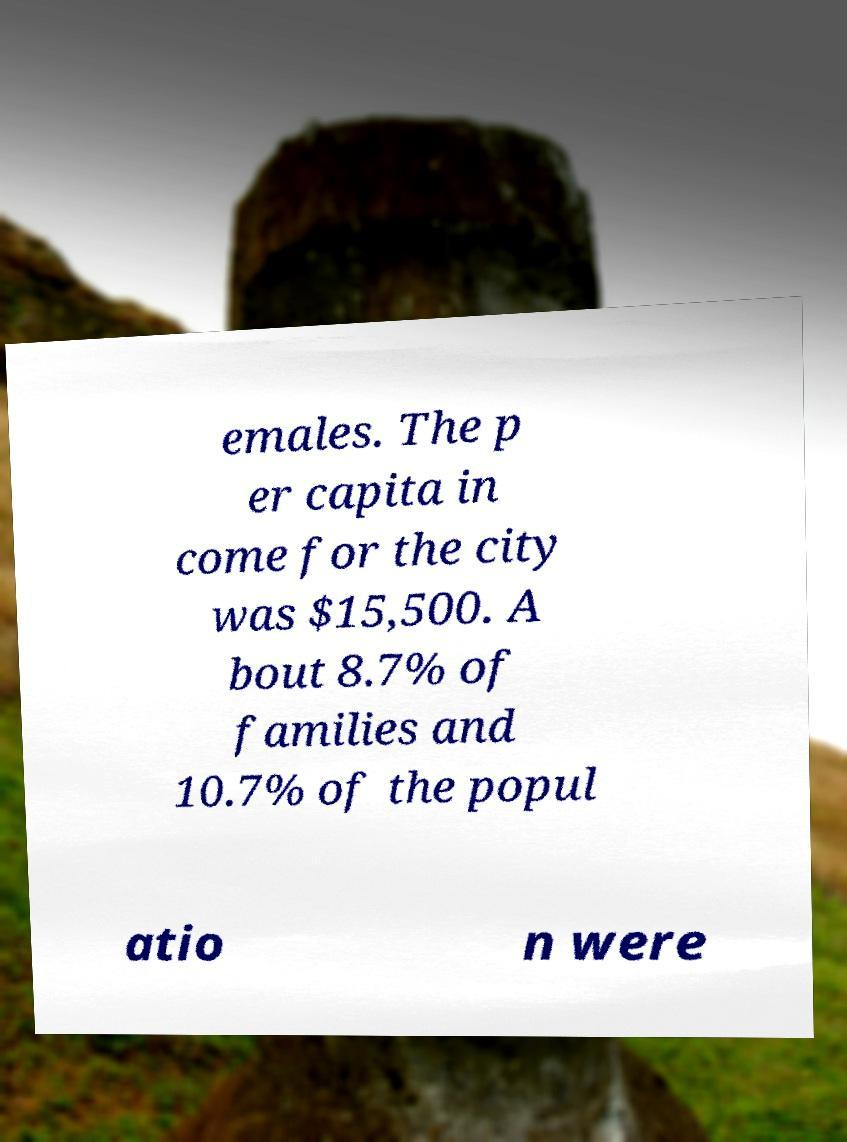Can you read and provide the text displayed in the image?This photo seems to have some interesting text. Can you extract and type it out for me? emales. The p er capita in come for the city was $15,500. A bout 8.7% of families and 10.7% of the popul atio n were 